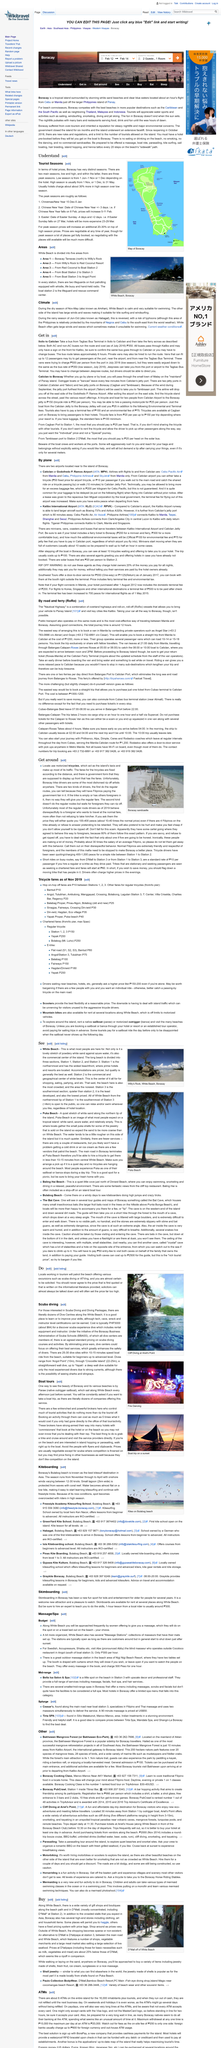Indicate a few pertinent items in this graphic. Christmas and New Year are typically considered to be in the high season for tourism. The two main seasons in Boracay are low and high, which refer to the dry and wet seasons, respectively. The increase in prices during peak season ranges from 20% to 30% over high season prices. 